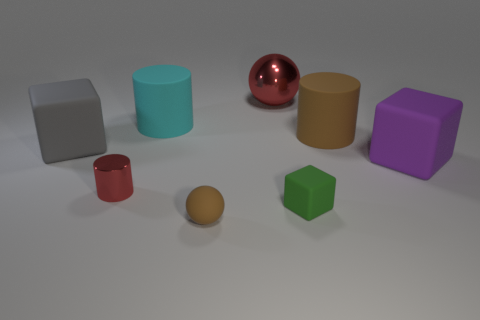Describe the lighting in this scene. Where do you think the light is coming from? The lighting in the scene is soft and diffuse, casting gentle shadows beneath the objects. It suggests an overhead light source, possibly from a large light or window out of the frame above the scene. 